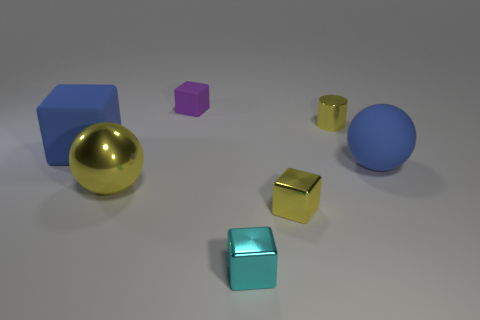The large blue matte object that is on the right side of the blue object left of the metallic thing that is behind the big blue matte ball is what shape?
Provide a succinct answer. Sphere. Are there any purple spheres made of the same material as the tiny cyan thing?
Keep it short and to the point. No. Do the block that is to the left of the tiny purple matte cube and the big object that is in front of the rubber sphere have the same color?
Your answer should be compact. No. Is the number of yellow cubes on the left side of the tiny purple block less than the number of cyan things?
Offer a terse response. Yes. How many objects are either small yellow shiny cubes or yellow objects that are in front of the large metallic ball?
Provide a succinct answer. 1. The cylinder that is the same material as the large yellow ball is what color?
Keep it short and to the point. Yellow. What number of things are either large objects or cyan metal objects?
Make the answer very short. 4. There is a matte cube that is the same size as the blue matte sphere; what color is it?
Your answer should be compact. Blue. How many things are large matte objects that are on the left side of the large metallic sphere or tiny shiny cylinders?
Ensure brevity in your answer.  2. What number of other objects are there of the same size as the cyan object?
Make the answer very short. 3. 